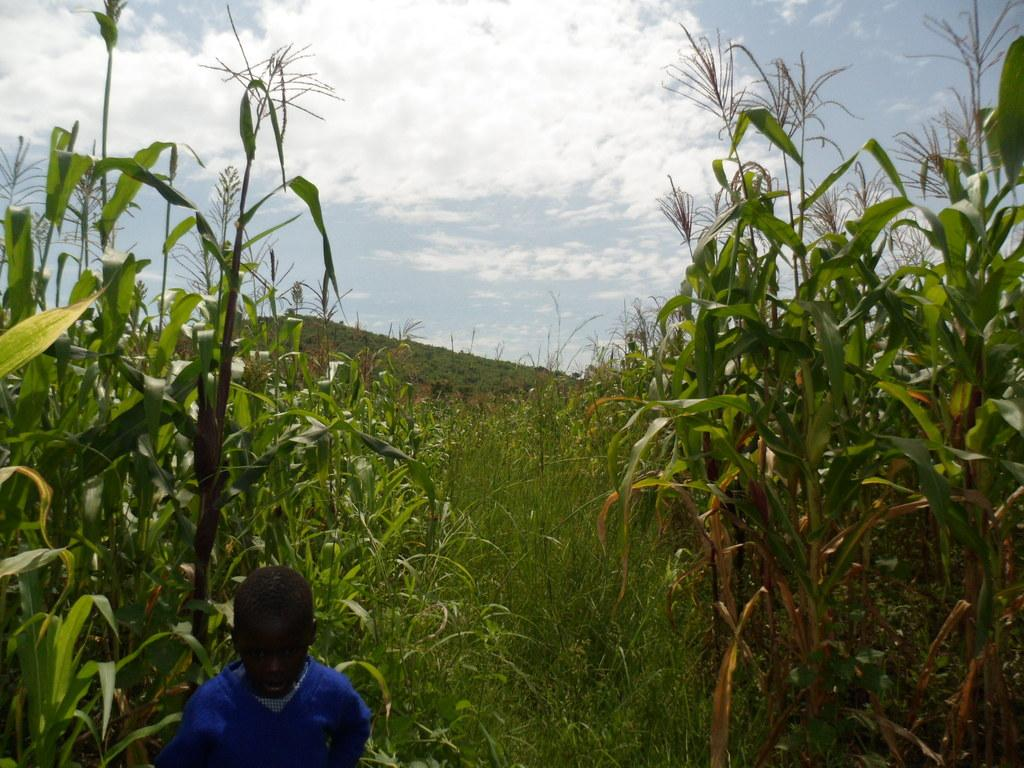Who is present in the image? There is a person in the image. What is the person wearing? The person is wearing a blue dress. What can be seen in the background of the image? There are plants in the background of the image. What is the color of the plants? The plants are green. What is visible above the plants in the image? The sky is visible in the image. What colors can be seen in the sky? The sky has both white and blue colors. What type of slip can be seen on the person's feet in the image? There is no slip visible on the person's feet in the image. Who is the father of the person in the image? The provided facts do not mention any information about the person's father, so it cannot be determined from the image. 